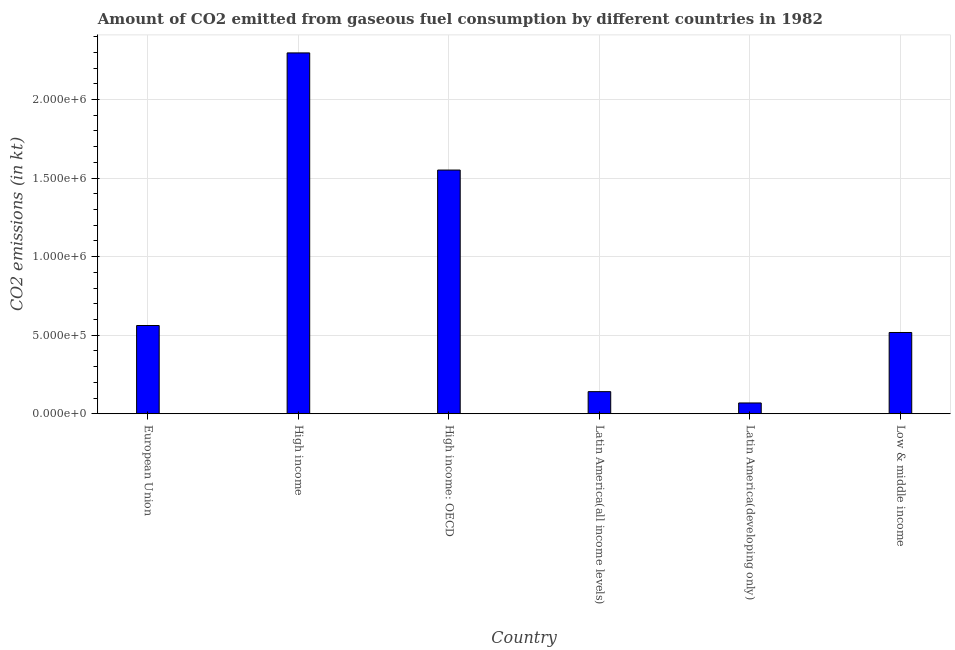Does the graph contain any zero values?
Offer a terse response. No. What is the title of the graph?
Your answer should be very brief. Amount of CO2 emitted from gaseous fuel consumption by different countries in 1982. What is the label or title of the X-axis?
Offer a very short reply. Country. What is the label or title of the Y-axis?
Provide a short and direct response. CO2 emissions (in kt). What is the co2 emissions from gaseous fuel consumption in Low & middle income?
Provide a short and direct response. 5.17e+05. Across all countries, what is the maximum co2 emissions from gaseous fuel consumption?
Your answer should be compact. 2.30e+06. Across all countries, what is the minimum co2 emissions from gaseous fuel consumption?
Make the answer very short. 6.86e+04. In which country was the co2 emissions from gaseous fuel consumption minimum?
Keep it short and to the point. Latin America(developing only). What is the sum of the co2 emissions from gaseous fuel consumption?
Offer a very short reply. 5.14e+06. What is the difference between the co2 emissions from gaseous fuel consumption in High income and Latin America(developing only)?
Give a very brief answer. 2.23e+06. What is the average co2 emissions from gaseous fuel consumption per country?
Your answer should be compact. 8.56e+05. What is the median co2 emissions from gaseous fuel consumption?
Provide a short and direct response. 5.39e+05. In how many countries, is the co2 emissions from gaseous fuel consumption greater than 2100000 kt?
Your answer should be very brief. 1. What is the ratio of the co2 emissions from gaseous fuel consumption in High income to that in Low & middle income?
Your response must be concise. 4.44. What is the difference between the highest and the second highest co2 emissions from gaseous fuel consumption?
Make the answer very short. 7.46e+05. What is the difference between the highest and the lowest co2 emissions from gaseous fuel consumption?
Provide a succinct answer. 2.23e+06. In how many countries, is the co2 emissions from gaseous fuel consumption greater than the average co2 emissions from gaseous fuel consumption taken over all countries?
Your answer should be very brief. 2. How many countries are there in the graph?
Offer a terse response. 6. What is the CO2 emissions (in kt) of European Union?
Offer a terse response. 5.62e+05. What is the CO2 emissions (in kt) of High income?
Your response must be concise. 2.30e+06. What is the CO2 emissions (in kt) in High income: OECD?
Your answer should be compact. 1.55e+06. What is the CO2 emissions (in kt) of Latin America(all income levels)?
Offer a terse response. 1.41e+05. What is the CO2 emissions (in kt) of Latin America(developing only)?
Ensure brevity in your answer.  6.86e+04. What is the CO2 emissions (in kt) of Low & middle income?
Provide a succinct answer. 5.17e+05. What is the difference between the CO2 emissions (in kt) in European Union and High income?
Offer a very short reply. -1.74e+06. What is the difference between the CO2 emissions (in kt) in European Union and High income: OECD?
Offer a very short reply. -9.90e+05. What is the difference between the CO2 emissions (in kt) in European Union and Latin America(all income levels)?
Offer a very short reply. 4.21e+05. What is the difference between the CO2 emissions (in kt) in European Union and Latin America(developing only)?
Make the answer very short. 4.93e+05. What is the difference between the CO2 emissions (in kt) in European Union and Low & middle income?
Your answer should be compact. 4.45e+04. What is the difference between the CO2 emissions (in kt) in High income and High income: OECD?
Keep it short and to the point. 7.46e+05. What is the difference between the CO2 emissions (in kt) in High income and Latin America(all income levels)?
Provide a short and direct response. 2.16e+06. What is the difference between the CO2 emissions (in kt) in High income and Latin America(developing only)?
Keep it short and to the point. 2.23e+06. What is the difference between the CO2 emissions (in kt) in High income and Low & middle income?
Your answer should be very brief. 1.78e+06. What is the difference between the CO2 emissions (in kt) in High income: OECD and Latin America(all income levels)?
Offer a very short reply. 1.41e+06. What is the difference between the CO2 emissions (in kt) in High income: OECD and Latin America(developing only)?
Ensure brevity in your answer.  1.48e+06. What is the difference between the CO2 emissions (in kt) in High income: OECD and Low & middle income?
Provide a short and direct response. 1.03e+06. What is the difference between the CO2 emissions (in kt) in Latin America(all income levels) and Latin America(developing only)?
Ensure brevity in your answer.  7.21e+04. What is the difference between the CO2 emissions (in kt) in Latin America(all income levels) and Low & middle income?
Provide a succinct answer. -3.77e+05. What is the difference between the CO2 emissions (in kt) in Latin America(developing only) and Low & middle income?
Offer a terse response. -4.49e+05. What is the ratio of the CO2 emissions (in kt) in European Union to that in High income?
Ensure brevity in your answer.  0.24. What is the ratio of the CO2 emissions (in kt) in European Union to that in High income: OECD?
Provide a succinct answer. 0.36. What is the ratio of the CO2 emissions (in kt) in European Union to that in Latin America(all income levels)?
Keep it short and to the point. 3.99. What is the ratio of the CO2 emissions (in kt) in European Union to that in Latin America(developing only)?
Provide a short and direct response. 8.19. What is the ratio of the CO2 emissions (in kt) in European Union to that in Low & middle income?
Give a very brief answer. 1.09. What is the ratio of the CO2 emissions (in kt) in High income to that in High income: OECD?
Offer a very short reply. 1.48. What is the ratio of the CO2 emissions (in kt) in High income to that in Latin America(all income levels)?
Your answer should be very brief. 16.33. What is the ratio of the CO2 emissions (in kt) in High income to that in Latin America(developing only)?
Ensure brevity in your answer.  33.49. What is the ratio of the CO2 emissions (in kt) in High income to that in Low & middle income?
Make the answer very short. 4.44. What is the ratio of the CO2 emissions (in kt) in High income: OECD to that in Latin America(all income levels)?
Ensure brevity in your answer.  11.03. What is the ratio of the CO2 emissions (in kt) in High income: OECD to that in Latin America(developing only)?
Provide a succinct answer. 22.62. What is the ratio of the CO2 emissions (in kt) in Latin America(all income levels) to that in Latin America(developing only)?
Keep it short and to the point. 2.05. What is the ratio of the CO2 emissions (in kt) in Latin America(all income levels) to that in Low & middle income?
Provide a succinct answer. 0.27. What is the ratio of the CO2 emissions (in kt) in Latin America(developing only) to that in Low & middle income?
Make the answer very short. 0.13. 